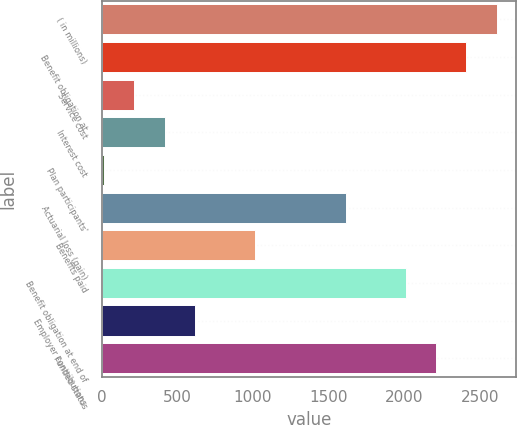Convert chart to OTSL. <chart><loc_0><loc_0><loc_500><loc_500><bar_chart><fcel>( in millions)<fcel>Benefit obligation at<fcel>Service cost<fcel>Interest cost<fcel>Plan participants'<fcel>Actuarial loss (gain)<fcel>Benefits paid<fcel>Benefit obligation at end of<fcel>Employer contributions<fcel>Funded status<nl><fcel>2611.5<fcel>2412<fcel>217.5<fcel>417<fcel>18<fcel>1614<fcel>1015.5<fcel>2013<fcel>616.5<fcel>2212.5<nl></chart> 